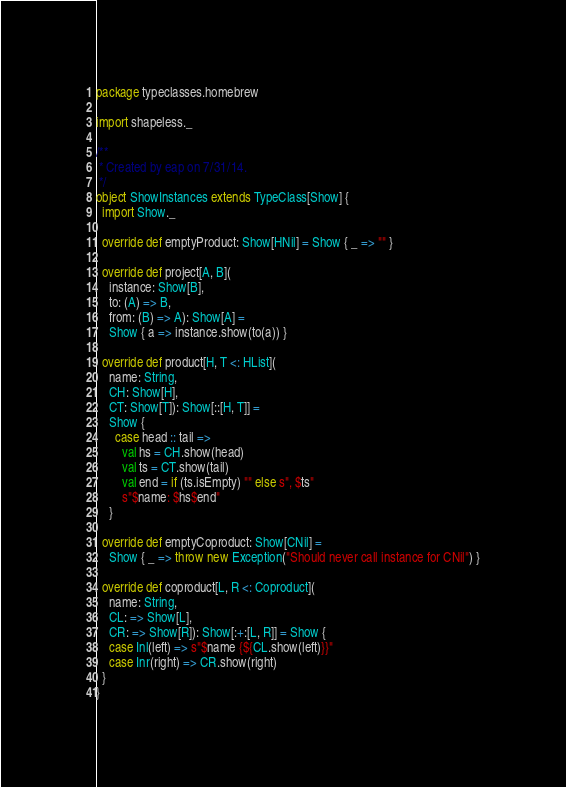Convert code to text. <code><loc_0><loc_0><loc_500><loc_500><_Scala_>package typeclasses.homebrew

import shapeless._

/**
 * Created by eap on 7/31/14.
 */
object ShowInstances extends TypeClass[Show] {
  import Show._

  override def emptyProduct: Show[HNil] = Show { _ => "" }

  override def project[A, B](
    instance: Show[B],
    to: (A) => B,
    from: (B) => A): Show[A] =
    Show { a => instance.show(to(a)) }

  override def product[H, T <: HList](
    name: String,
    CH: Show[H],
    CT: Show[T]): Show[::[H, T]] =
    Show {
      case head :: tail =>
        val hs = CH.show(head)
        val ts = CT.show(tail)
        val end = if (ts.isEmpty) "" else s", $ts"
        s"$name: $hs$end"
    }

  override def emptyCoproduct: Show[CNil] =
    Show { _ => throw new Exception("Should never call instance for CNil") }

  override def coproduct[L, R <: Coproduct](
    name: String,
    CL: => Show[L],
    CR: => Show[R]): Show[:+:[L, R]] = Show {
    case Inl(left) => s"$name {${CL.show(left)}}"
    case Inr(right) => CR.show(right)
  }
}
</code> 